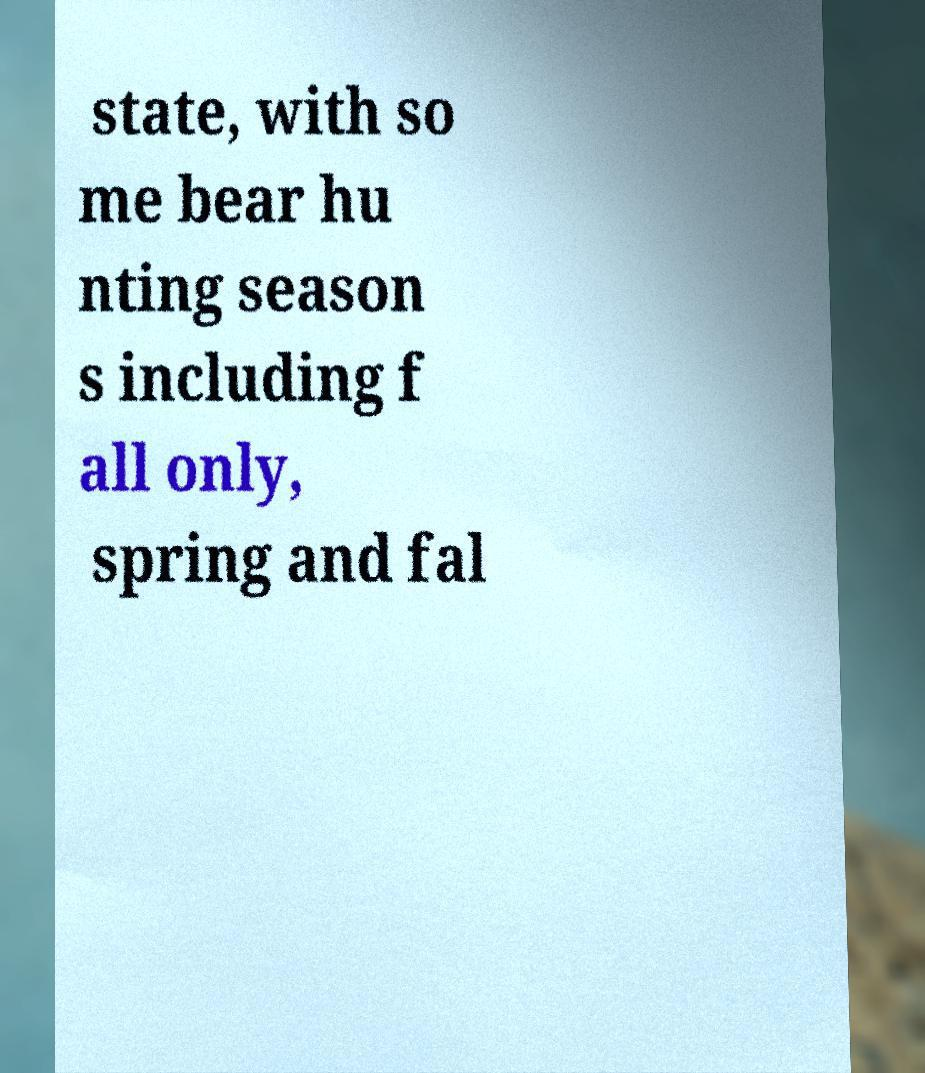Can you accurately transcribe the text from the provided image for me? state, with so me bear hu nting season s including f all only, spring and fal 